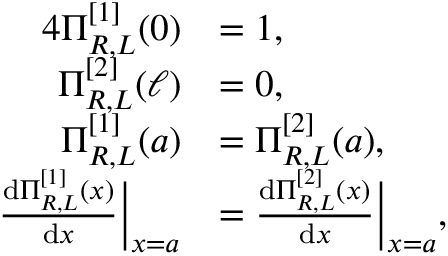<formula> <loc_0><loc_0><loc_500><loc_500>\begin{array} { r l } { { 4 } \Pi _ { R , L } ^ { [ 1 ] } ( 0 ) } & { = 1 , } \\ { \Pi _ { R , L } ^ { [ 2 ] } ( \ell ) } & { = 0 , } \\ { \Pi _ { R , L } ^ { [ 1 ] } ( a ) } & { = \Pi _ { R , L } ^ { [ 2 ] } ( a ) , } \\ { \frac { d \Pi _ { R , L } ^ { [ 1 ] } ( x ) } { d x } \left | _ { x = a } } & { = \frac { d \Pi _ { R , L } ^ { [ 2 ] } ( x ) } { d x } \right | _ { x = a } , } \end{array}</formula> 